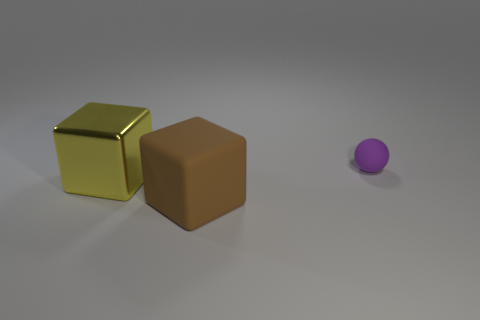The rubber object on the left side of the small sphere is what color?
Offer a terse response. Brown. The matte object that is the same size as the metallic cube is what color?
Make the answer very short. Brown. Is the shape of the big yellow metallic thing the same as the small purple object?
Provide a succinct answer. No. There is a thing on the left side of the matte block; what is its material?
Ensure brevity in your answer.  Metal. The small sphere is what color?
Ensure brevity in your answer.  Purple. There is a thing in front of the large metallic cube; is it the same size as the thing that is on the left side of the large brown rubber cube?
Your answer should be compact. Yes. There is a thing that is both on the right side of the metal thing and in front of the purple matte thing; what size is it?
Offer a terse response. Large. There is another big thing that is the same shape as the large metallic object; what is its color?
Provide a short and direct response. Brown. Are there more small purple objects that are behind the large shiny thing than brown matte cubes that are behind the purple rubber object?
Your response must be concise. Yes. How many other things are there of the same shape as the brown rubber object?
Keep it short and to the point. 1. 